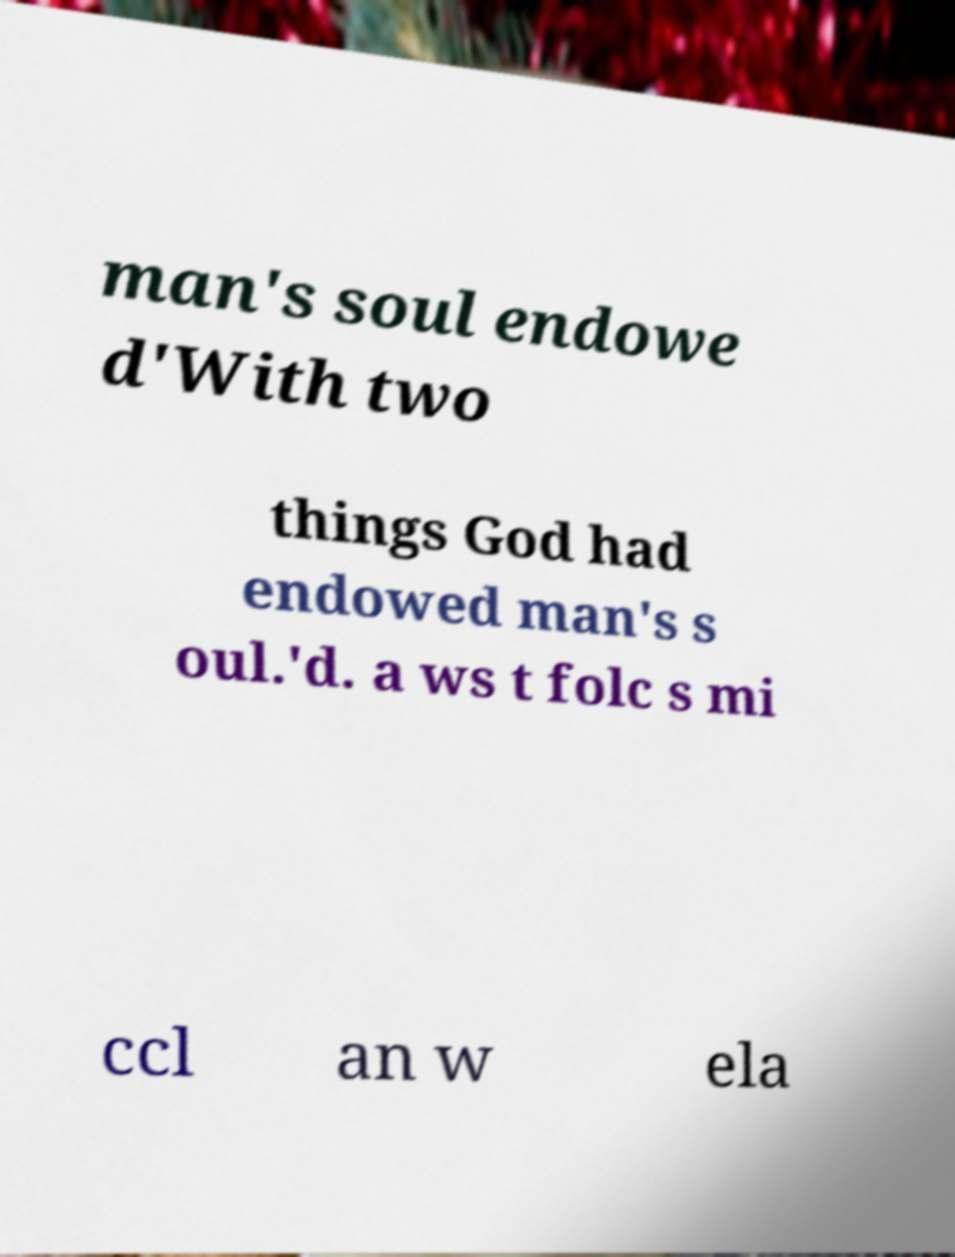Could you extract and type out the text from this image? man's soul endowe d'With two things God had endowed man's s oul.'d. a ws t folc s mi ccl an w ela 